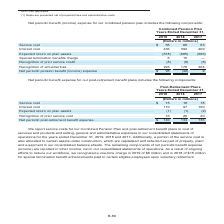According to Centurylink's financial document, What was recognized as a result of ongoing efforts to reduce the company's workforce? a one-time charge in 2019 of $6 million and in 2018 of $15 million for special termination benefit enhancements paid to certain eligible employees upon voluntary retirement. The document states: "ng efforts to reduce our workforce, we recognized a one-time charge in 2019 of $6 million and in 2018 of $15 million for special termination benefit e..." Also, Where are the remaining components of net periodic benefit expense (income) reported? in other income, net in our consolidated statements of operations. The document states: "et periodic benefit expense (income) are reported in other income, net in our consolidated statements of operations. As a result of ongoing efforts to..." Also, Which are the components included in the net periodic benefit expense for the post-retirement benefit plans? The document contains multiple relevant values: service cost, interest cost, expected return on plan assets, recognition of prior service cost, net periodic post-retirement benefit expense. From the document: "(Dollars in millions) Service cost . $ 15 18 18 Interest cost . 110 97 100 Expected return on plan assets . (1) (1) (2) Recognition of prior service c..." Also, How many components are included in the net periodic benefit expense reported for the post-retirement benefit plans? Counting the relevant items in the document: service cost, interest cost, expected return on plan assets, recognition of prior service cost, net periodic post-retirement benefit expense, I find 5 instances. The key data points involved are: expected return on plan assets, interest cost, net periodic post-retirement benefit expense. Also, can you calculate: What is the sum of service costs in 2017, 2018 and 2019? Based on the calculation: 15+18+18, the result is 51 (in millions). This is based on the information: "2019 2018 2017 85) (666) Special termination benefits charge . 6 15 — Recognition of prior service credit . (8) (8) (8) Recognition of actuarial loss . 223 178 204..." The key data points involved are: 15, 18. Also, can you calculate: What is the average amount of service costs across 2017, 2018 and 2019? To answer this question, I need to perform calculations using the financial data. The calculation is: (15+18+18)/3, which equals 17 (in millions). This is based on the information: "2019 2018 2017 85) (666) Special termination benefits charge . 6 15 — Recognition of prior service credit . (8) (8) (8) Recognition of actuarial loss . 223 178 204..." The key data points involved are: 15, 18. 